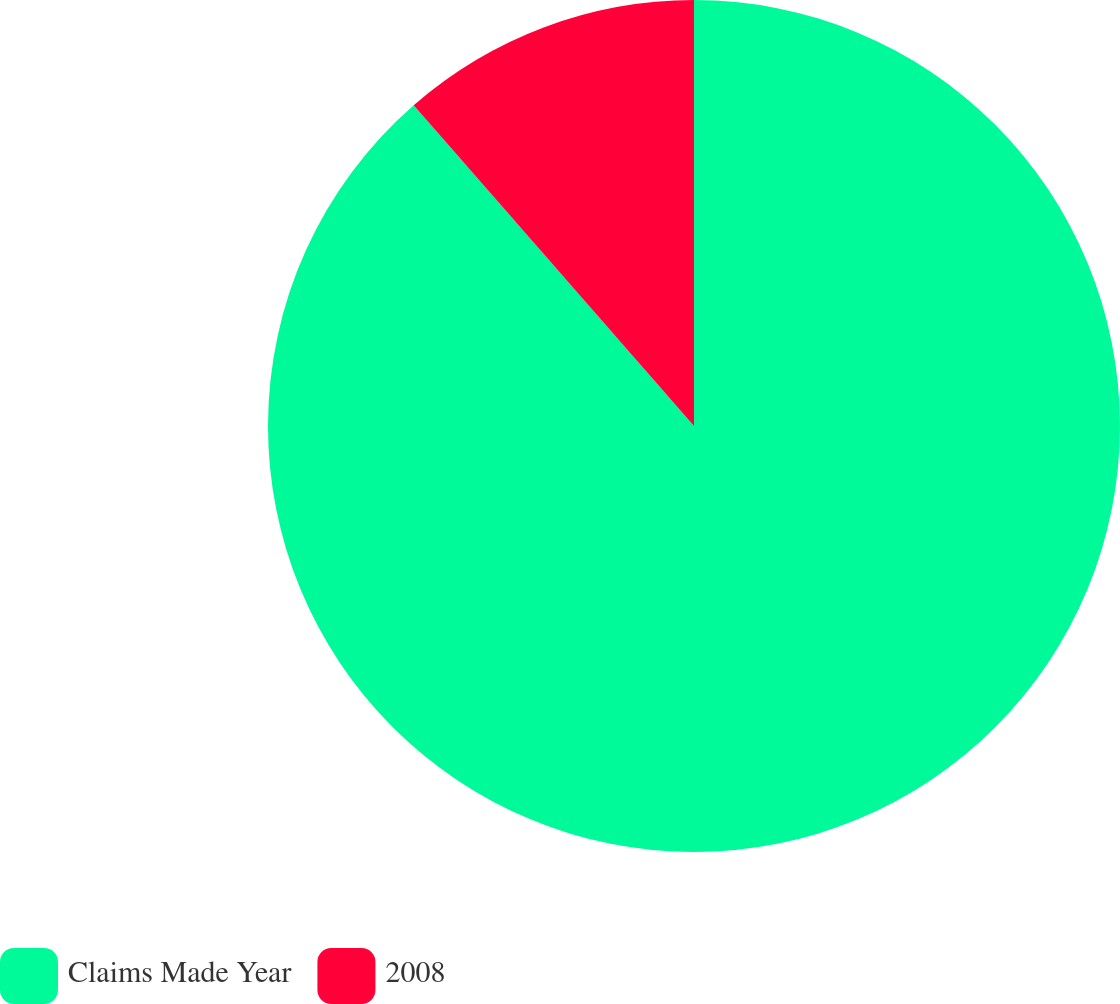<chart> <loc_0><loc_0><loc_500><loc_500><pie_chart><fcel>Claims Made Year<fcel>2008<nl><fcel>88.57%<fcel>11.43%<nl></chart> 